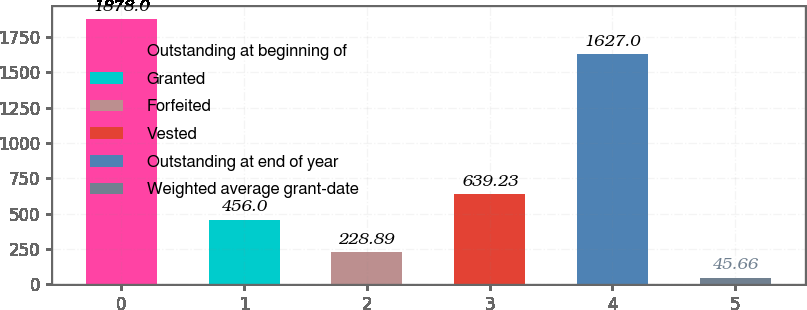Convert chart. <chart><loc_0><loc_0><loc_500><loc_500><bar_chart><fcel>Outstanding at beginning of<fcel>Granted<fcel>Forfeited<fcel>Vested<fcel>Outstanding at end of year<fcel>Weighted average grant-date<nl><fcel>1878<fcel>456<fcel>228.89<fcel>639.23<fcel>1627<fcel>45.66<nl></chart> 